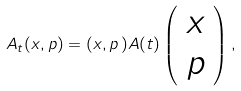<formula> <loc_0><loc_0><loc_500><loc_500>A _ { t } ( x , p ) = ( x , p \, ) A ( t ) \left ( \begin{array} { c } x \\ p \\ \end{array} \right ) ,</formula> 